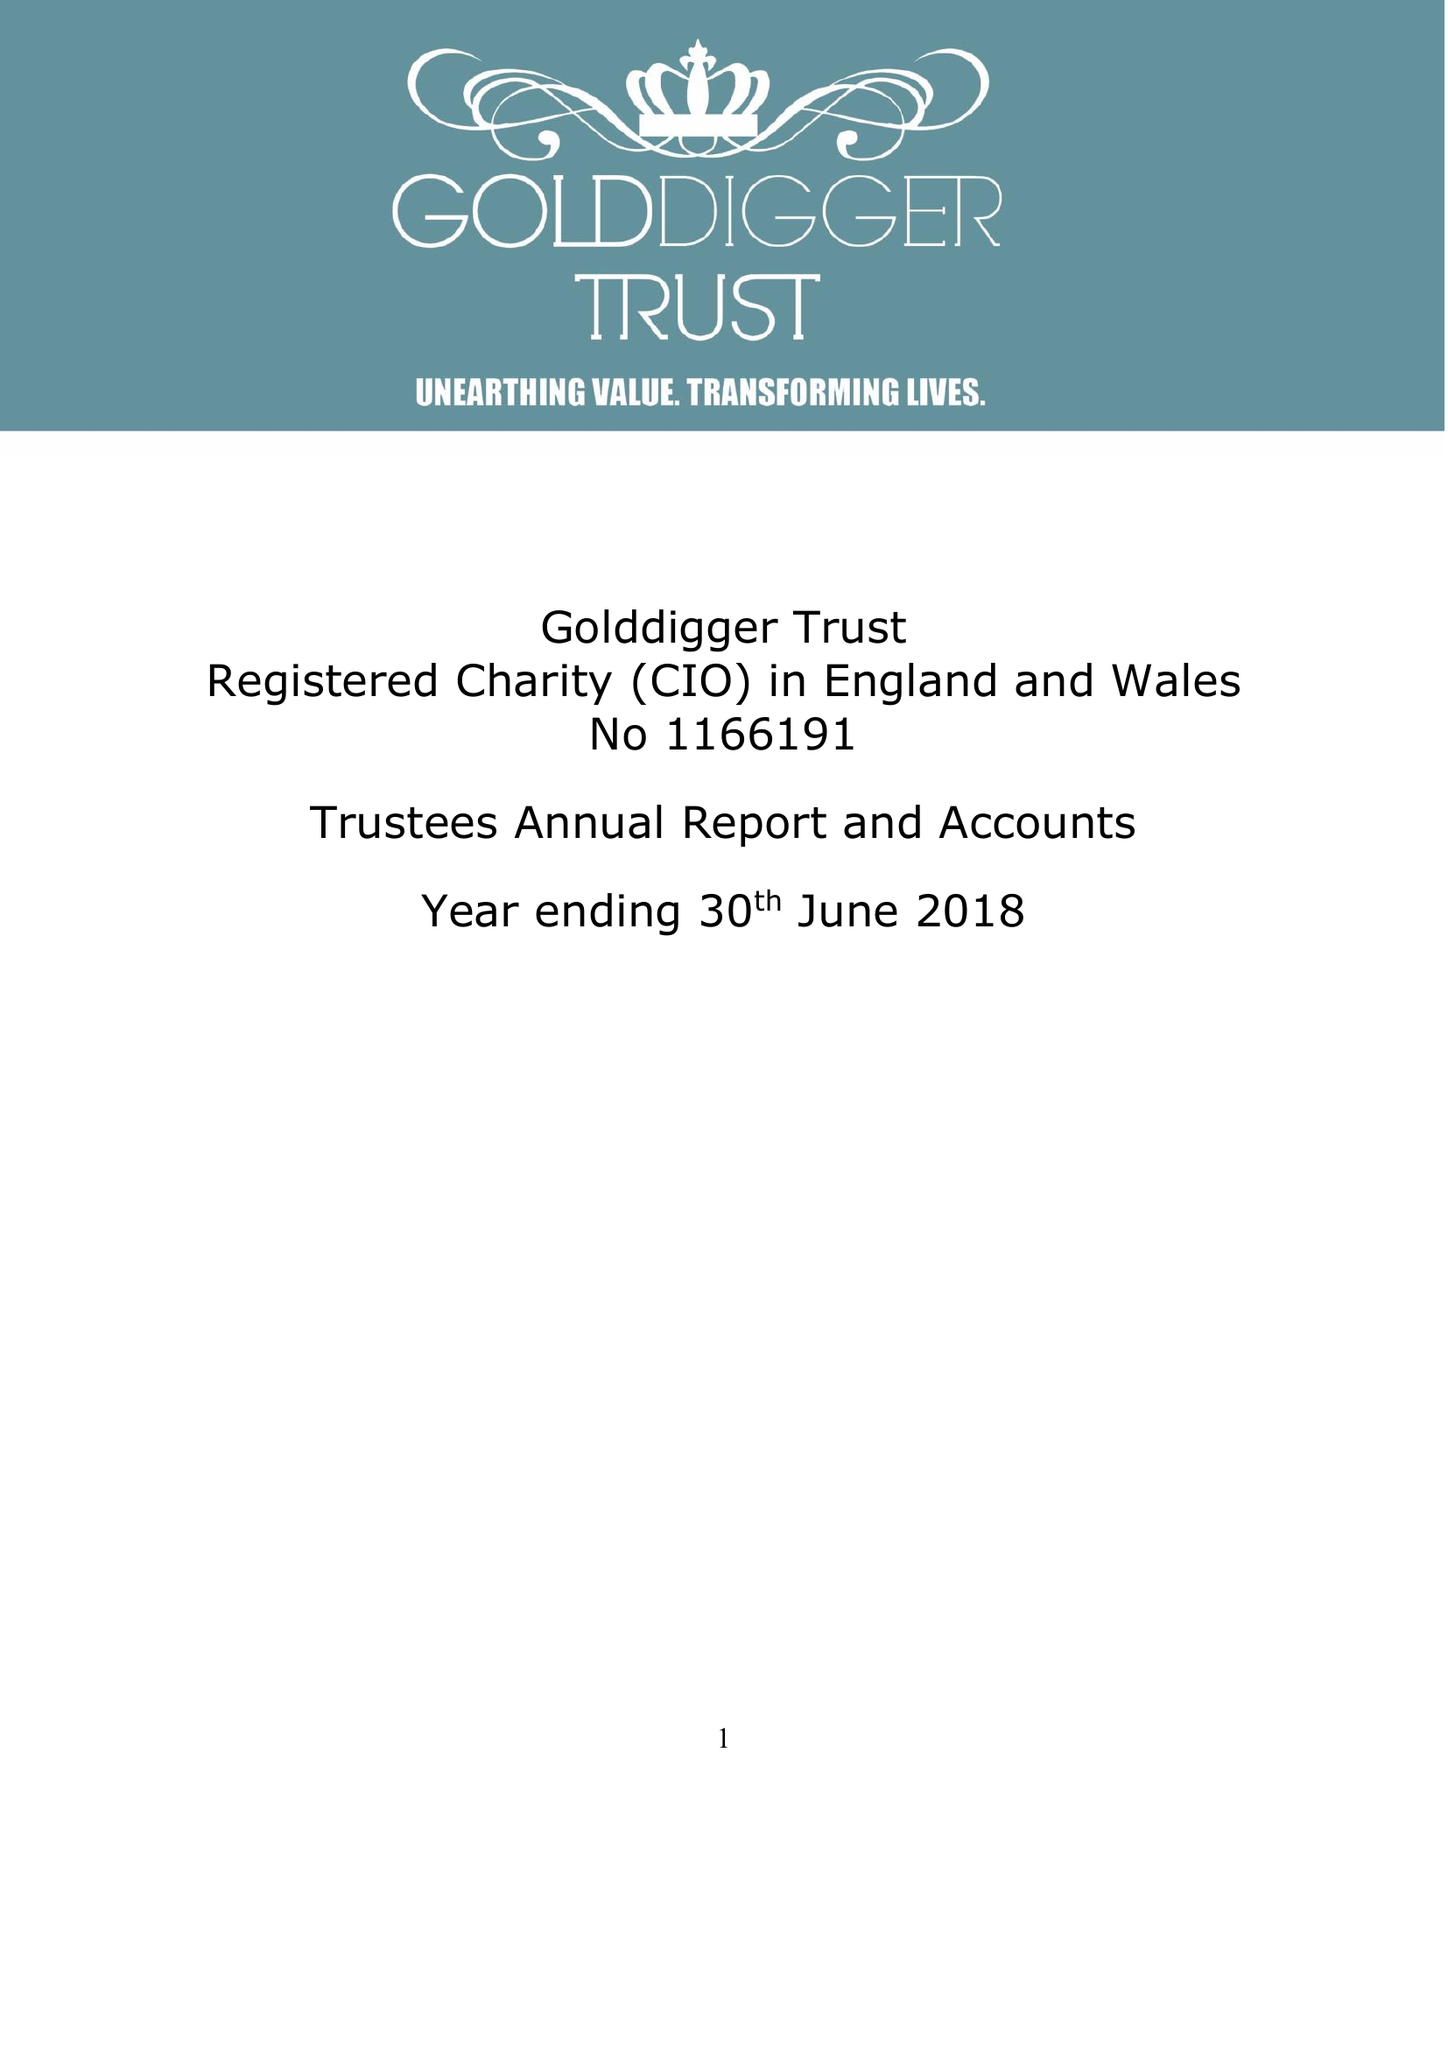What is the value for the address__post_town?
Answer the question using a single word or phrase. SHEFFIELD 